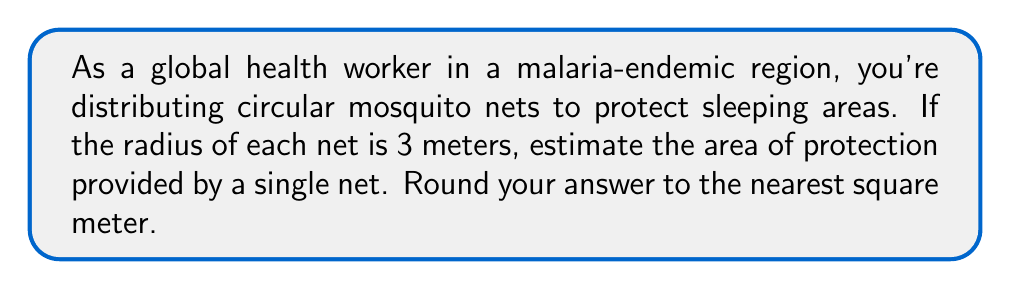Can you solve this math problem? To solve this problem, we need to use the formula for the area of a circle:

$$A = \pi r^2$$

Where:
$A$ = area of the circle
$\pi$ (pi) ≈ 3.14159
$r$ = radius of the circle

Given:
$r = 3$ meters

Let's calculate the area:

$$\begin{align*}
A &= \pi r^2 \\
&= \pi \cdot (3\text{ m})^2 \\
&= \pi \cdot 9\text{ m}^2 \\
&\approx 3.14159 \cdot 9\text{ m}^2 \\
&\approx 28.27431\text{ m}^2
\end{align*}$$

Rounding to the nearest square meter:

$$28.27431\text{ m}^2 \approx 28\text{ m}^2$$

Therefore, the estimated area of protection provided by a single circular mosquito net with a radius of 3 meters is approximately 28 square meters.
Answer: 28 square meters 